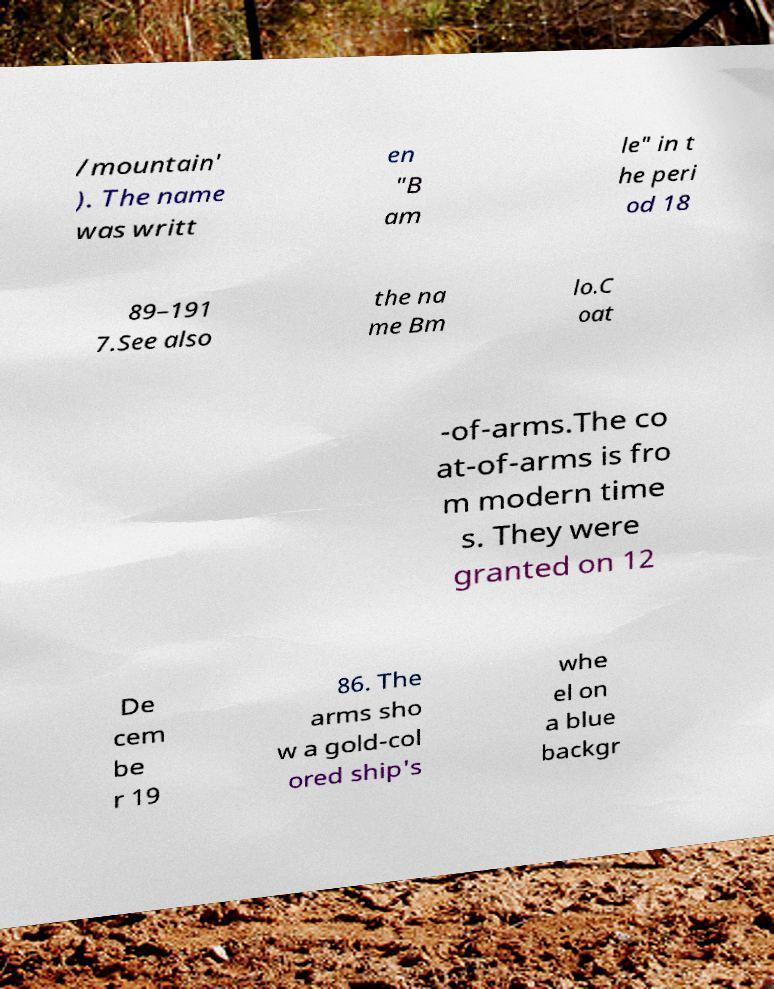What messages or text are displayed in this image? I need them in a readable, typed format. /mountain' ). The name was writt en "B am le" in t he peri od 18 89–191 7.See also the na me Bm lo.C oat -of-arms.The co at-of-arms is fro m modern time s. They were granted on 12 De cem be r 19 86. The arms sho w a gold-col ored ship's whe el on a blue backgr 